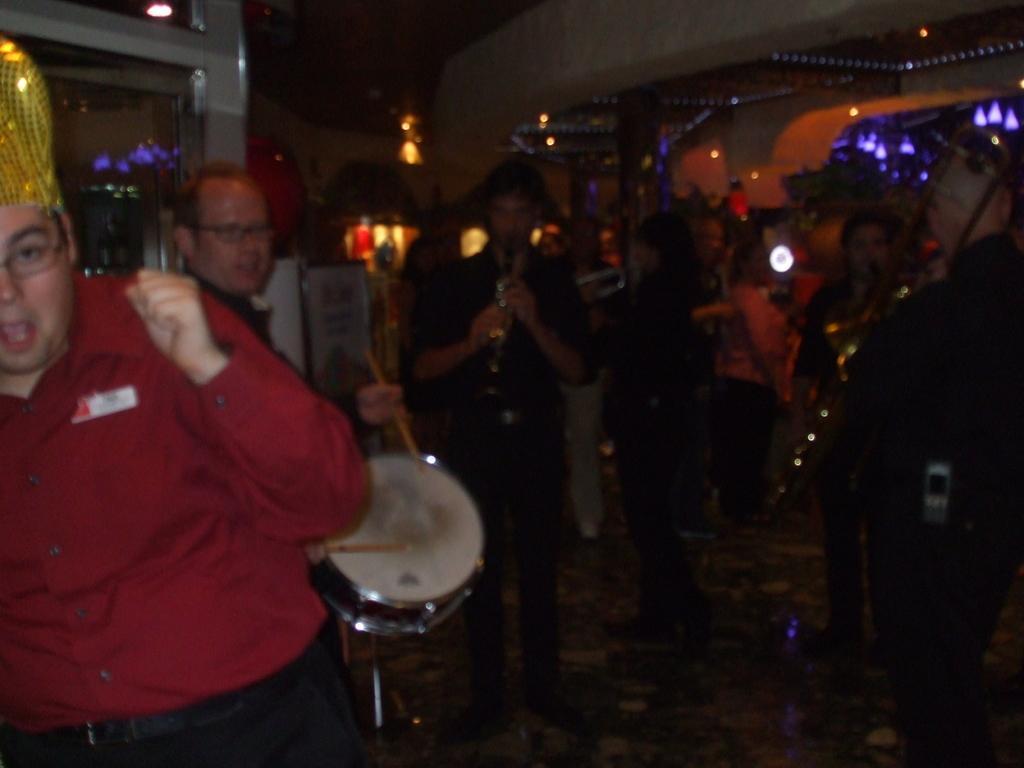Can you describe this image briefly? In this image I can see number of people are standing. I can see few of them are holding musical instruments. In the background I can see number of lights and I can see this image is little bit in dark. 